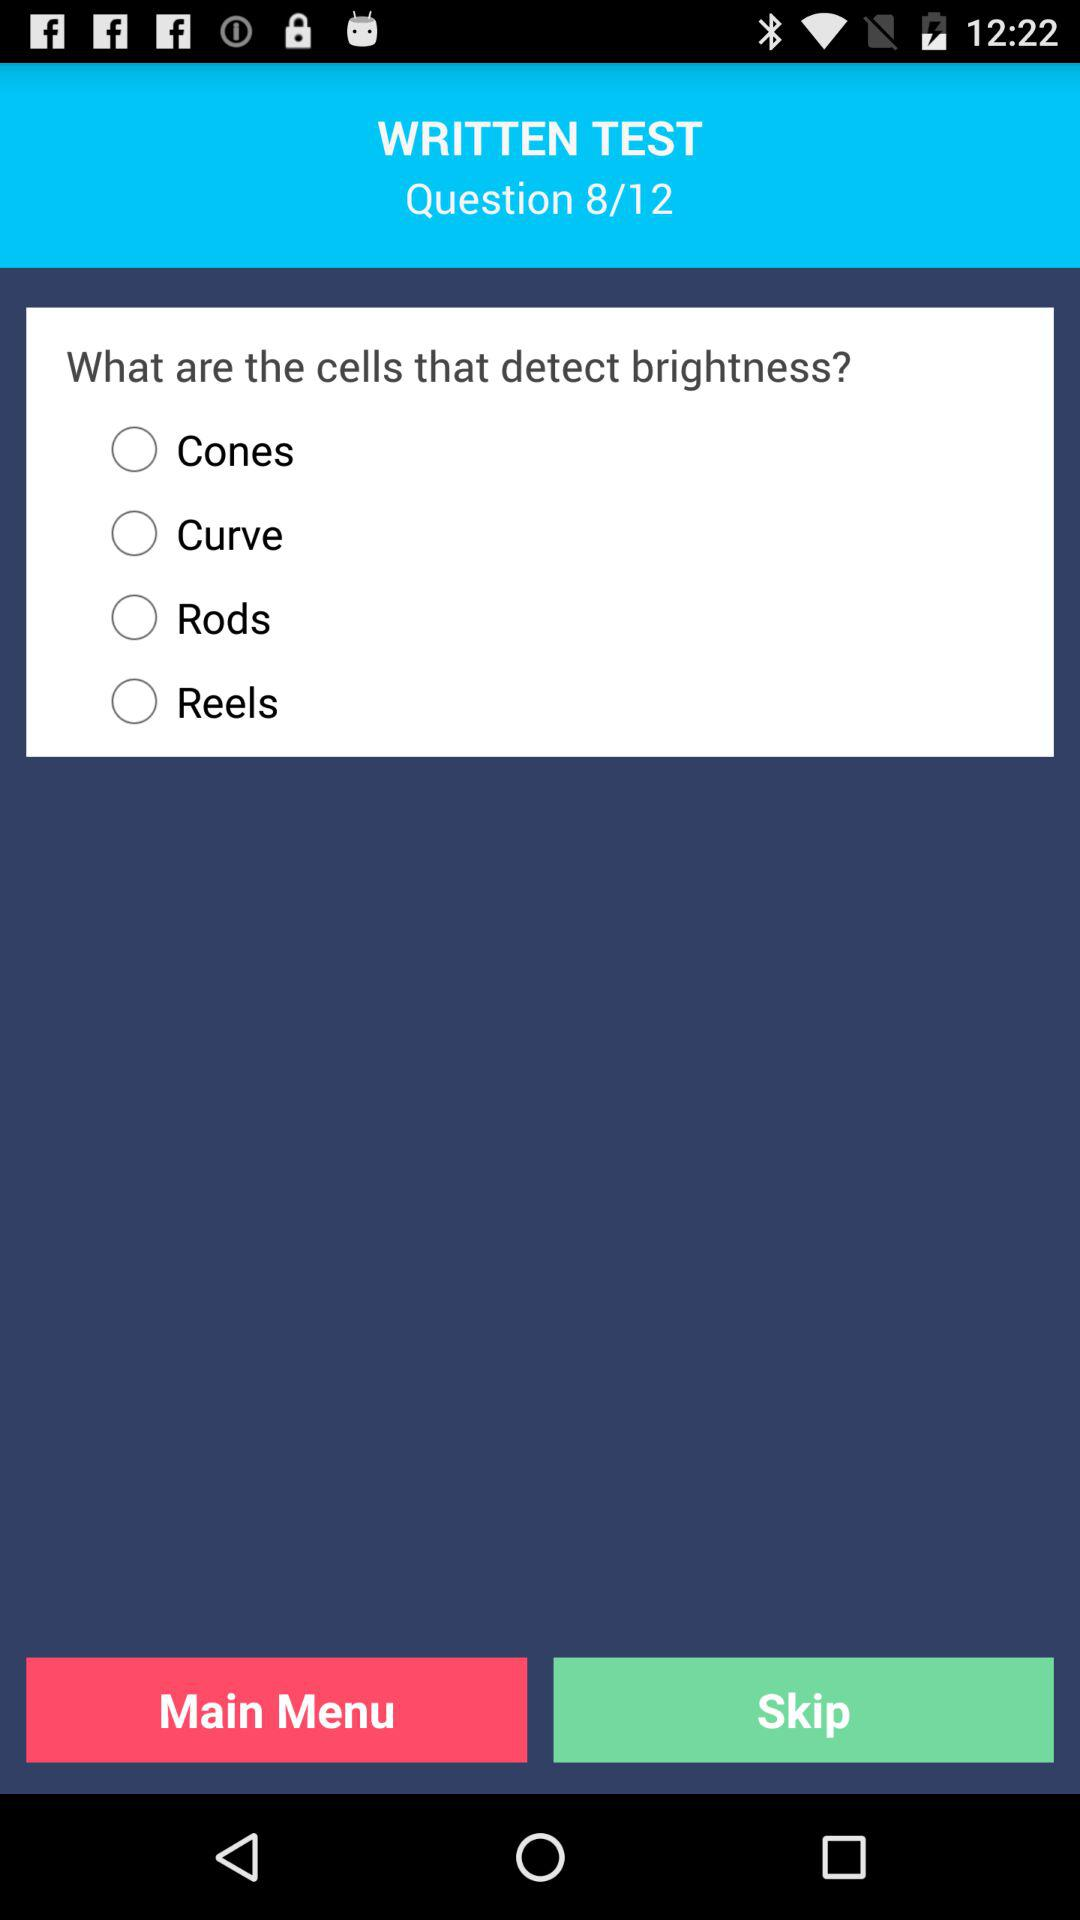How long does the user have to answer the question?
When the provided information is insufficient, respond with <no answer>. <no answer> 